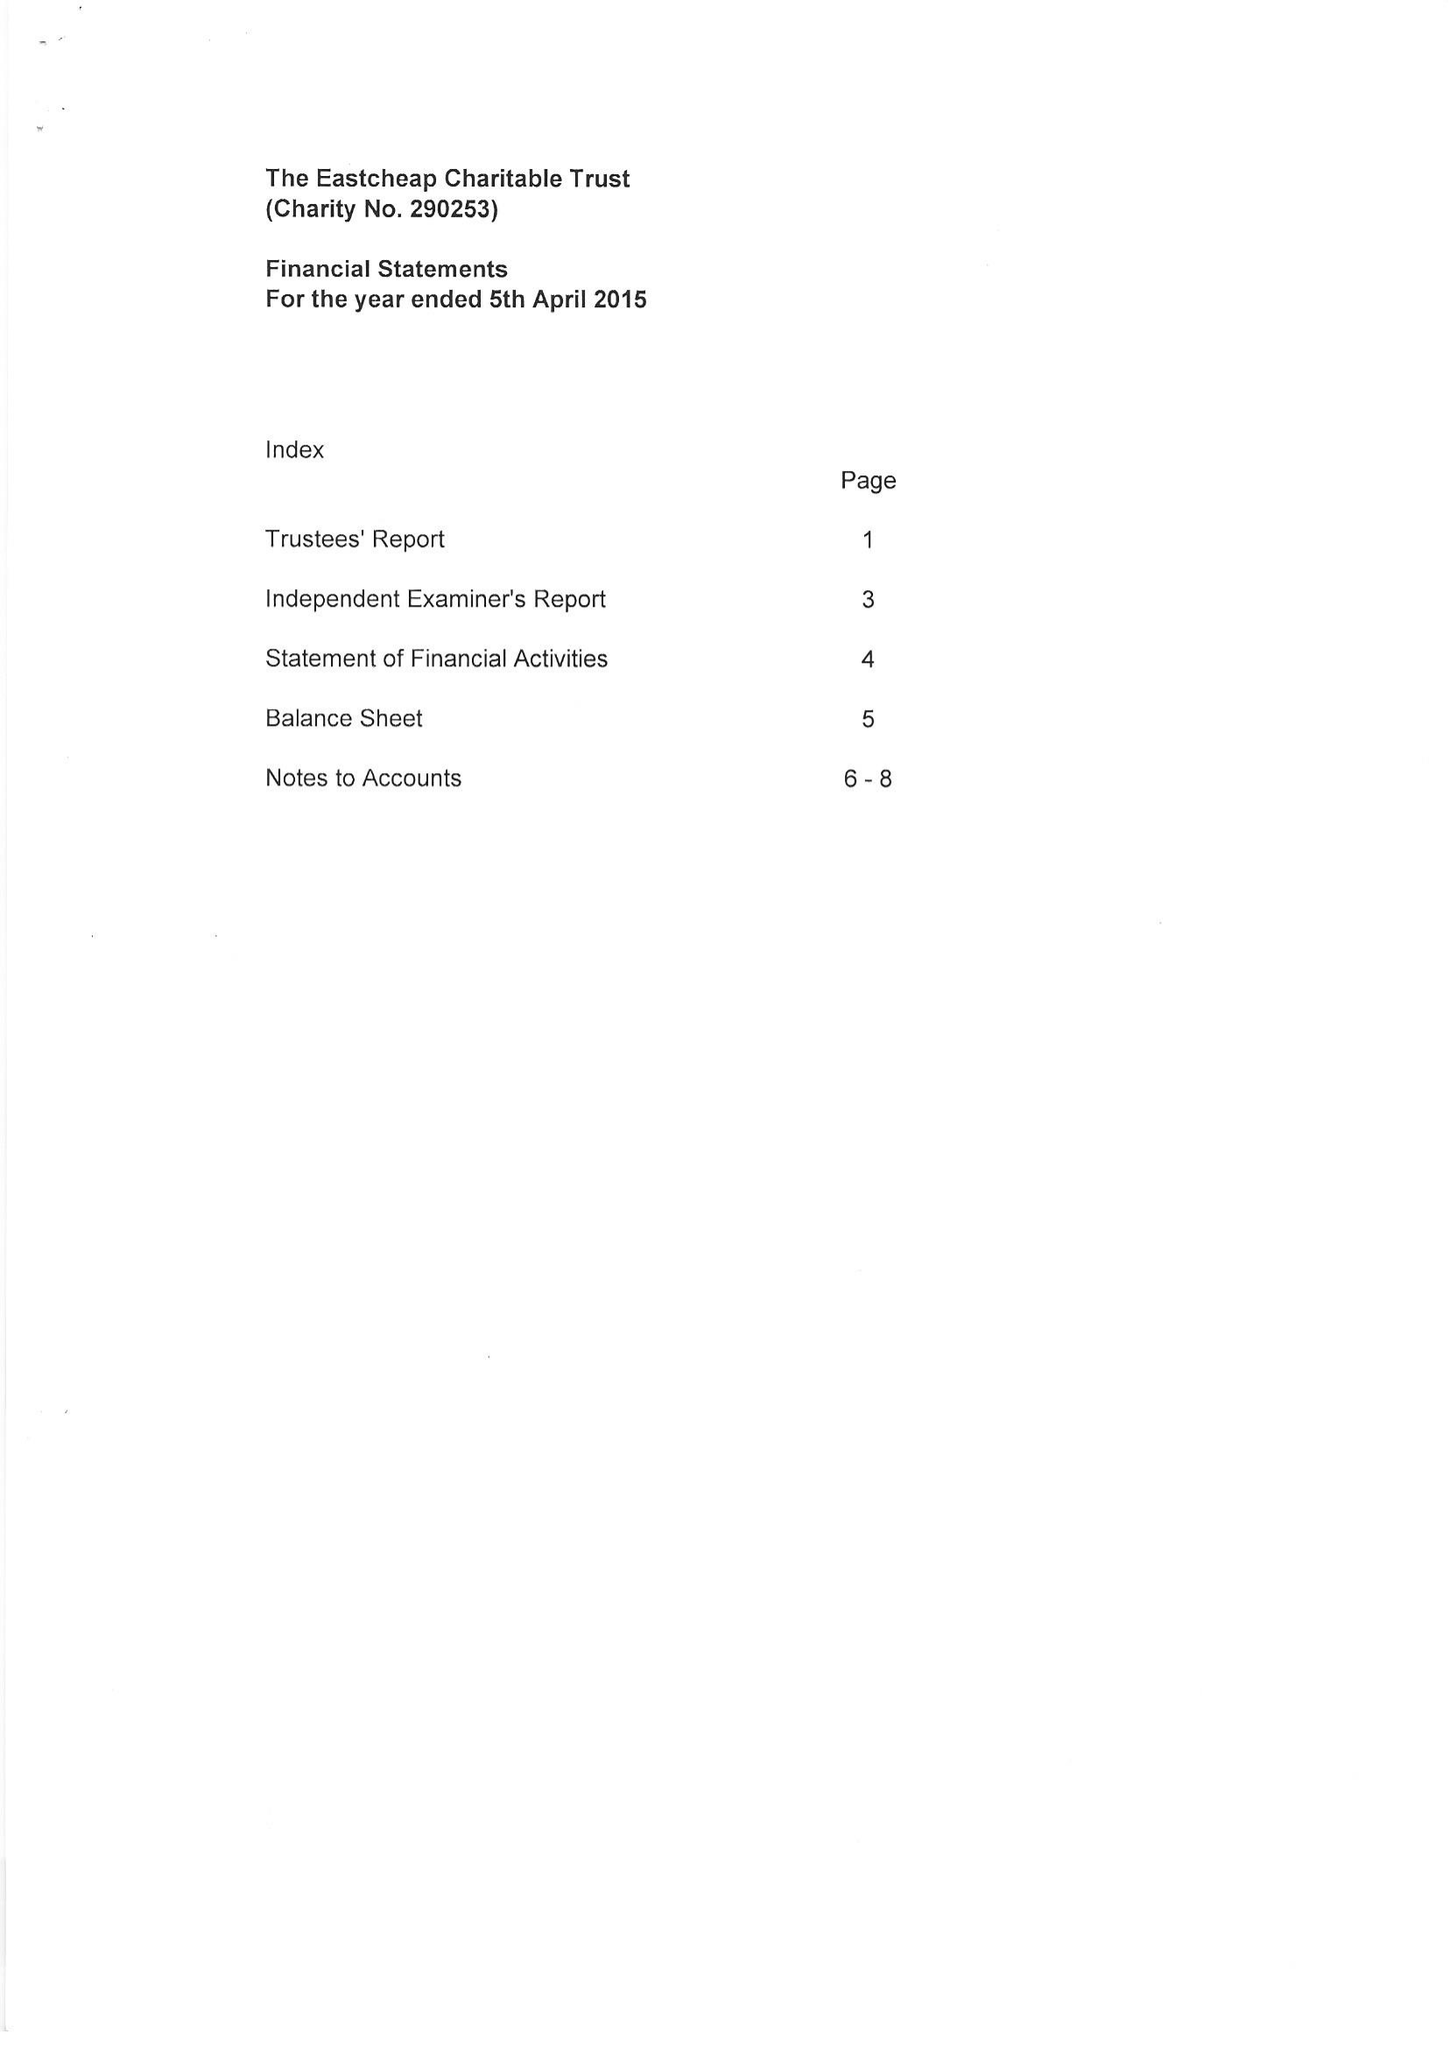What is the value for the spending_annually_in_british_pounds?
Answer the question using a single word or phrase. 105902.00 